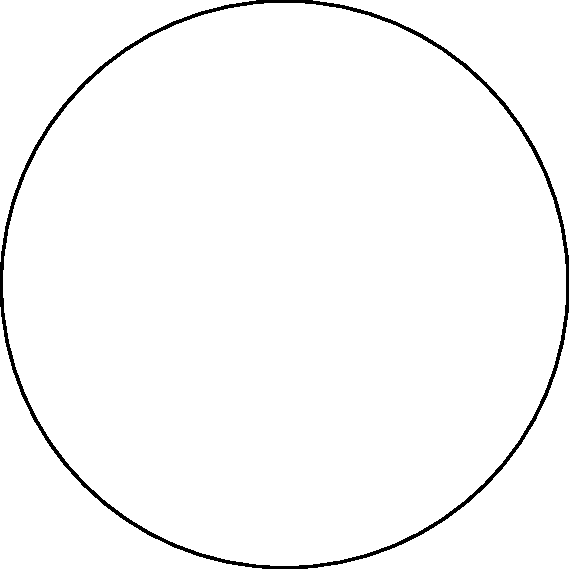In a hyperbolic plane represented by the Poincaré disk model, a regular quadrilateral ABCD is inscribed as shown in the figure. If the sum of the interior angles of this quadrilateral is $300°$, what is the measure of each interior angle? To solve this problem, let's follow these steps:

1) In Euclidean geometry, the sum of interior angles of a quadrilateral is always $360°$. However, in hyperbolic geometry, this sum is always less than $360°$.

2) We're given that the sum of the interior angles is $300°$.

3) Since the quadrilateral is regular, all interior angles are equal. Let's call the measure of each angle $x°$.

4) We can set up the equation:

   $4x = 300$

5) Solving for $x$:

   $x = 300 ÷ 4 = 75$

6) Therefore, each interior angle of the regular quadrilateral measures $75°$.

7) This result aligns with hyperbolic geometry principles. In a hyperbolic plane, the angle sum of a quadrilateral is less than $360°$, and the interior angles of a regular polygon are smaller than their Euclidean counterparts.

8) This property is crucial for suppliers dealing with non-Euclidean geometries in product designs or packaging, as it affects calculations and measurements in hyperbolic spaces.
Answer: $75°$ 